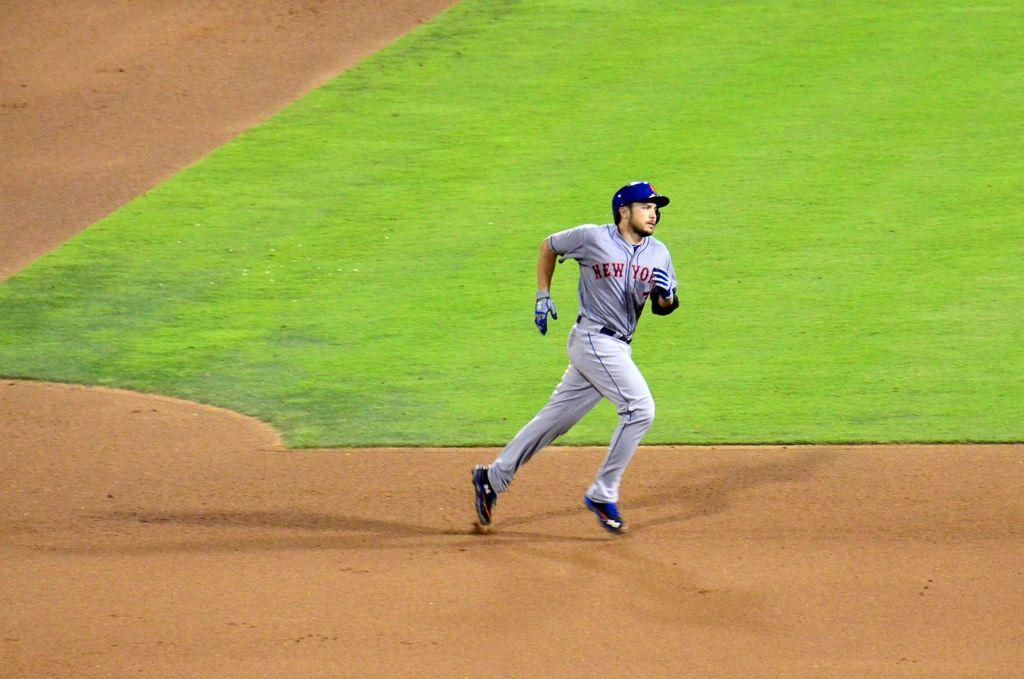<image>
Render a clear and concise summary of the photo. the man running in the field is wearing a New York jersey 